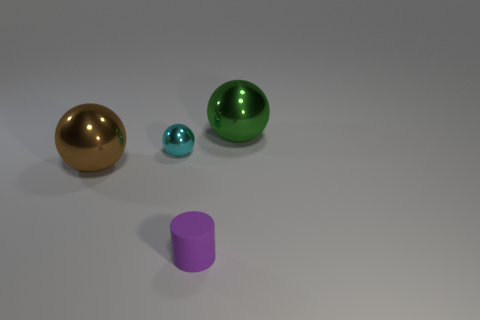Is there anything else that has the same material as the tiny purple object?
Offer a very short reply. No. Does the rubber cylinder have the same color as the small metal object?
Ensure brevity in your answer.  No. Are the purple cylinder and the big brown thing made of the same material?
Your answer should be compact. No. What number of tiny cyan spheres have the same material as the tiny purple cylinder?
Provide a short and direct response. 0. What is the color of the other large sphere that is the same material as the large brown ball?
Make the answer very short. Green. What is the shape of the matte object?
Make the answer very short. Cylinder. There is a large ball that is on the right side of the cyan thing; what is its material?
Give a very brief answer. Metal. Is there another object of the same color as the matte thing?
Offer a very short reply. No. There is a cyan thing that is the same size as the purple thing; what shape is it?
Provide a succinct answer. Sphere. The big sphere that is left of the tiny sphere is what color?
Offer a terse response. Brown. 